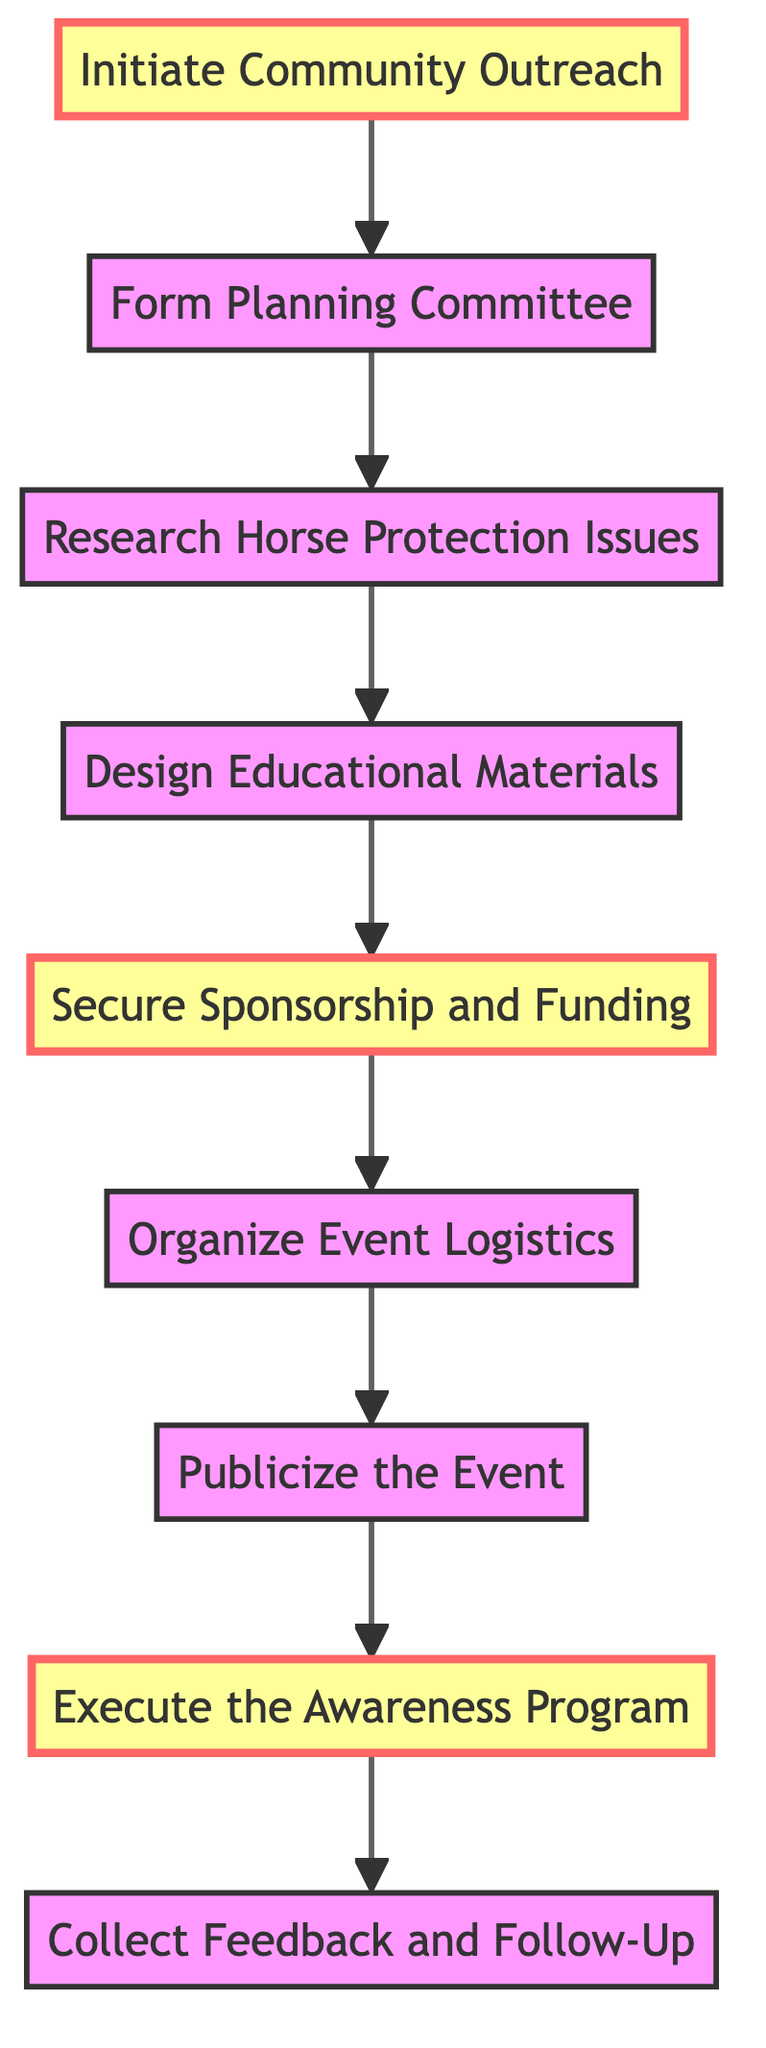What is the first step in the diagram? The first step is indicated as "Initiate Community Outreach," which is the node at the bottom of the flowchart.
Answer: Initiate Community Outreach How many total nodes are present in the diagram? Counting all the steps in the diagram from "Initiate Community Outreach" to "Collect Feedback and Follow-Up," there are a total of nine nodes.
Answer: Nine What step follows "Research Horse Protection Issues"? "Design Educational Materials" follows "Research Horse Protection Issues," as represented by the direct arrow that connects these two nodes in the sequence indicated in the flowchart.
Answer: Design Educational Materials Which steps are highlighted in the diagram? The highlighted steps in the diagram are "Initiate Community Outreach," "Design Educational Materials," and "Execute the Awareness Program," as denoted by the distinct coloring used for these nodes.
Answer: Initiate Community Outreach, Design Educational Materials, Execute the Awareness Program What is the last step in the flow chart? The last step is "Collect Feedback and Follow-Up," which is the node at the top of the flowchart, indicating that it is the final action to be taken after the awareness program.
Answer: Collect Feedback and Follow-Up How many steps are there between "Organize Event Logistics" and "Execute the Awareness Program"? There is one step between them. "Publicize the Event" is the direct intermediary step in the sequence from "Organize Event Logistics" to "Execute the Awareness Program."
Answer: One What action must be taken after "Publicize the Event"? After "Publicize the Event," the next action is "Execute the Awareness Program," according to the order of operations depicted in the flowchart.
Answer: Execute the Awareness Program Which step involves creating educational content? "Design Educational Materials" is the step that specifically mentions the creation of educational content, highlighting its importance in the overall effort to raise awareness about horse protection issues.
Answer: Design Educational Materials What does securing sponsorship and funding involve? Securing sponsorship and funding involves approaching local businesses, veterinary clinics, and equine supply stores to obtain financial support or donations for the awareness program.
Answer: Approach local businesses, veterinary clinics, equine supply stores 